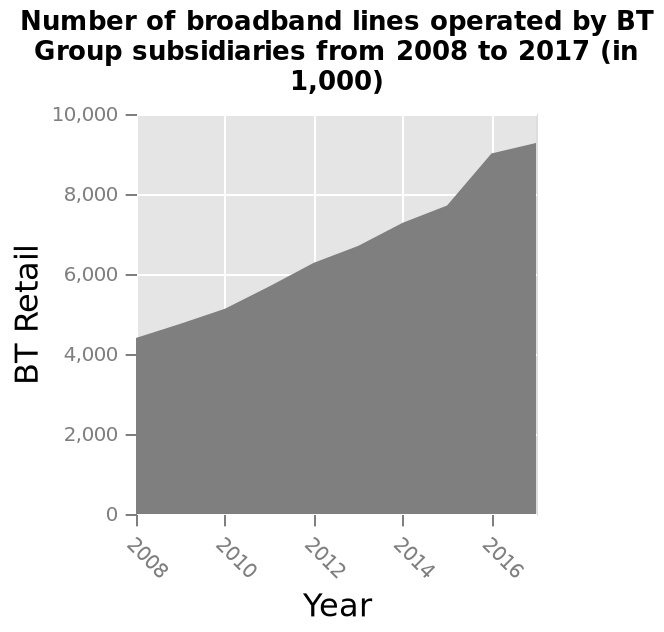<image>
How many broadband lines were operated by BT Group subsidiaries in 2017? In 2017, BT Group subsidiaries operated a total of 1,000 broadband lines. Did the number of broadband lines operated by BT Group subsidiaries increase or decrease from 2008 to 2017? We can't determine from the given information whether the number of broadband lines operated by BT Group subsidiaries increased or decreased. What is the range of years represented on the x-axis of the area graph? The range of years represented on the x-axis of the area graph is from 2008 to 2017. 